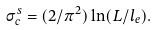<formula> <loc_0><loc_0><loc_500><loc_500>\sigma ^ { s } _ { c } = ( 2 / \pi ^ { 2 } ) \ln ( L / l _ { e } ) .</formula> 